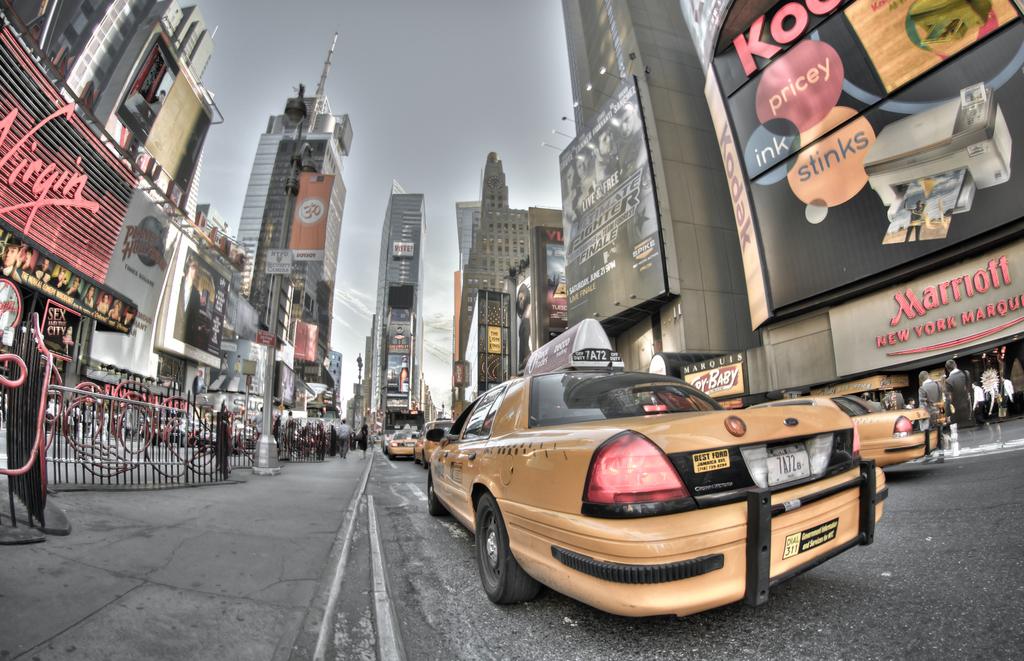What hotel is on the street?
Keep it short and to the point. Marriott. What company is on the left?
Provide a succinct answer. Virgin. 